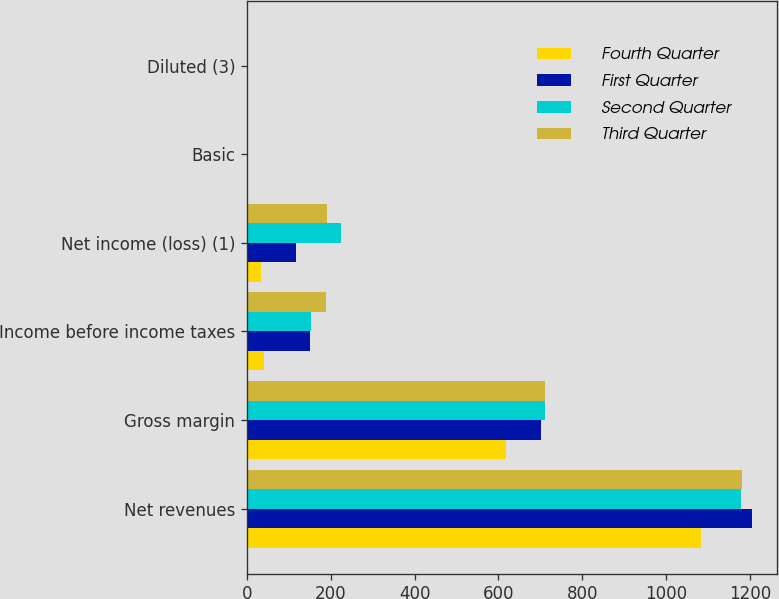Convert chart to OTSL. <chart><loc_0><loc_0><loc_500><loc_500><stacked_bar_chart><ecel><fcel>Net revenues<fcel>Gross margin<fcel>Income before income taxes<fcel>Net income (loss) (1)<fcel>Basic<fcel>Diluted (3)<nl><fcel>Fourth Quarter<fcel>1082.6<fcel>618.4<fcel>41.4<fcel>34.4<fcel>0.1<fcel>0.1<nl><fcel>First Quarter<fcel>1204.1<fcel>700.9<fcel>150.9<fcel>116.5<fcel>0.33<fcel>0.33<nl><fcel>Second Quarter<fcel>1179.8<fcel>711<fcel>152<fcel>223.8<fcel>0.65<fcel>0.64<nl><fcel>Third Quarter<fcel>1181<fcel>710.9<fcel>188.4<fcel>192.2<fcel>0.56<fcel>0.55<nl></chart> 